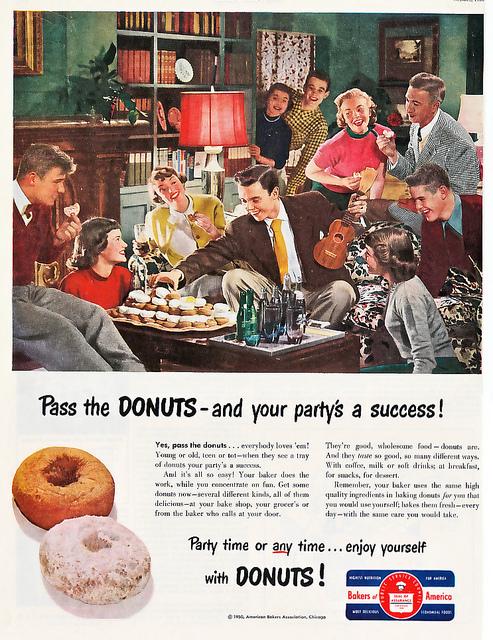What are the people celebrating?
Give a very brief answer. Donuts. What is this an ad for?
Answer briefly. Donuts. Is this a modern ad?
Short answer required. No. Is this a modern advertisement?
Be succinct. No. 